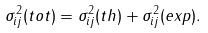<formula> <loc_0><loc_0><loc_500><loc_500>\sigma ^ { 2 } _ { i j } ( t o t ) = \sigma ^ { 2 } _ { i j } ( t h ) + \sigma ^ { 2 } _ { i j } ( e x p ) .</formula> 